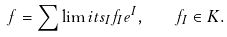Convert formula to latex. <formula><loc_0><loc_0><loc_500><loc_500>f = \sum \lim i t s _ { I } f _ { I } e ^ { I } , \quad f _ { I } \in K .</formula> 